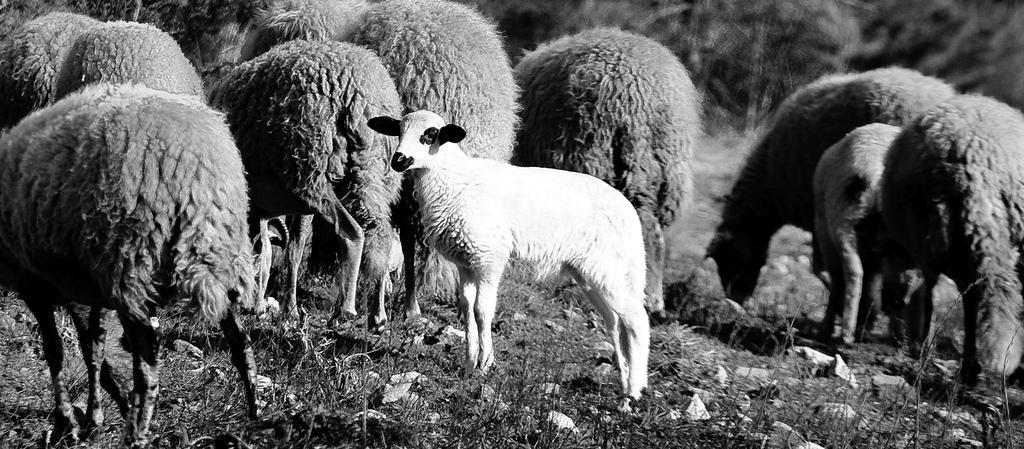What animals are present in the image? There is a herd of sheep in the image. What is the sheep's position in relation to the ground? The sheep are standing on the ground. What type of vegetation covers the ground in the image? The ground is covered with grass. What color scheme is used in the image? The image is in black and white color. How many minutes does it take for the fire to spread in the image? There is no fire present in the image, so it is not possible to determine how long it would take for a fire to spread. 